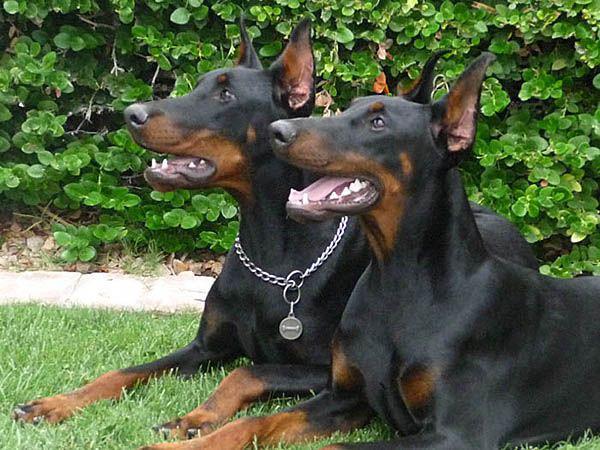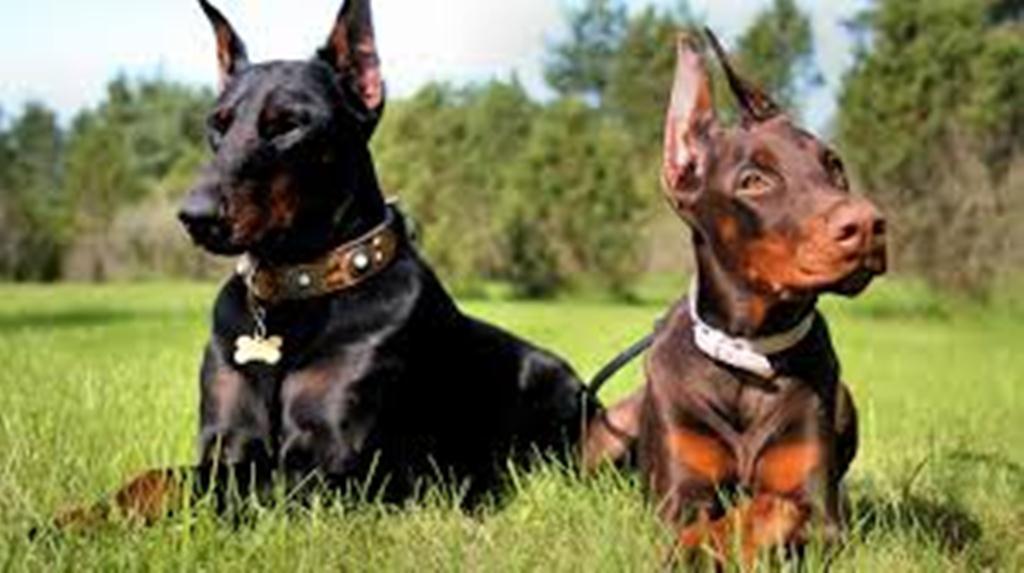The first image is the image on the left, the second image is the image on the right. Given the left and right images, does the statement "At least one dog has its mouth open in one picture and none do in the other." hold true? Answer yes or no. Yes. The first image is the image on the left, the second image is the image on the right. Considering the images on both sides, is "One image contains two dobermans sitting upright side-by side, and the other image features two dobermans reclining side-by-side." valid? Answer yes or no. No. 